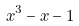<formula> <loc_0><loc_0><loc_500><loc_500>x ^ { 3 } - x - 1</formula> 